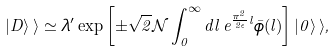Convert formula to latex. <formula><loc_0><loc_0><loc_500><loc_500>| D \rangle \, \rangle \simeq \lambda ^ { \prime } \exp \left [ \pm \sqrt { 2 } \mathcal { N } \int ^ { \infty } _ { 0 } d l \, e ^ { \frac { \pi ^ { 2 } } { 2 \epsilon } l } \bar { \phi } ( l ) \right ] | 0 \rangle \, \rangle ,</formula> 